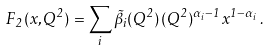Convert formula to latex. <formula><loc_0><loc_0><loc_500><loc_500>F _ { 2 } ( x , Q ^ { 2 } ) = \sum _ { i } \tilde { \beta } _ { i } ( Q ^ { 2 } ) \, ( Q ^ { 2 } ) ^ { \alpha _ { i } - 1 } \, x ^ { 1 - \alpha _ { i } } \, .</formula> 